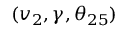<formula> <loc_0><loc_0><loc_500><loc_500>( v _ { 2 } , \gamma , \theta _ { 2 5 } )</formula> 